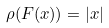<formula> <loc_0><loc_0><loc_500><loc_500>\rho ( F ( x ) ) = | x |</formula> 